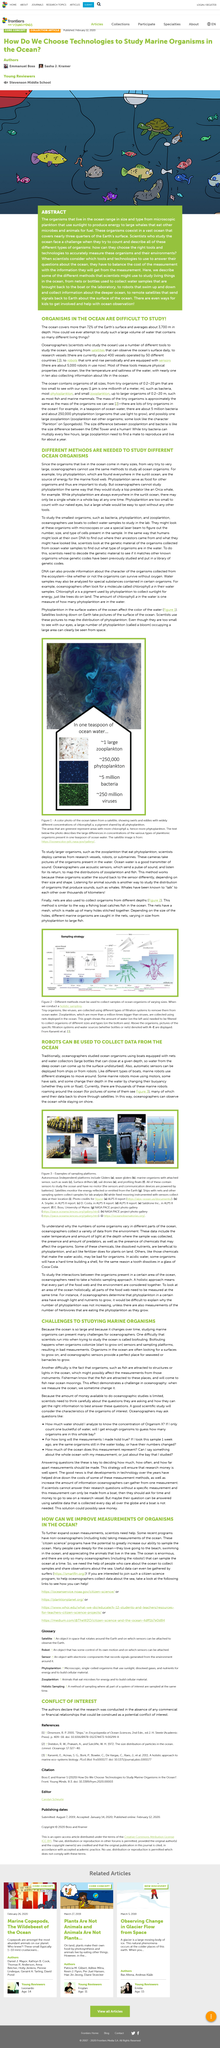Outline some significant characteristics in this image. Oceanographers have historically studied ocean organisms by deploying boats equipped with nets and water collectors to gather data and samples. Oceanographers study why the numbers of some organisms vary in different parts of the ocean by collecting a variety of data from the environment, such as temperature, salinity, and nutrient levels, to better understand the complex interactions between these factors and the organisms themselves. Yes, phytoplankton in the surface waters of the ocean do affect the color of the water. Phytoplankton are known to utilize chlorophyll as a means of photosynthesis. Large zooplankton are required to mate or multiply as they do not have the ability to reproduce on their own. 